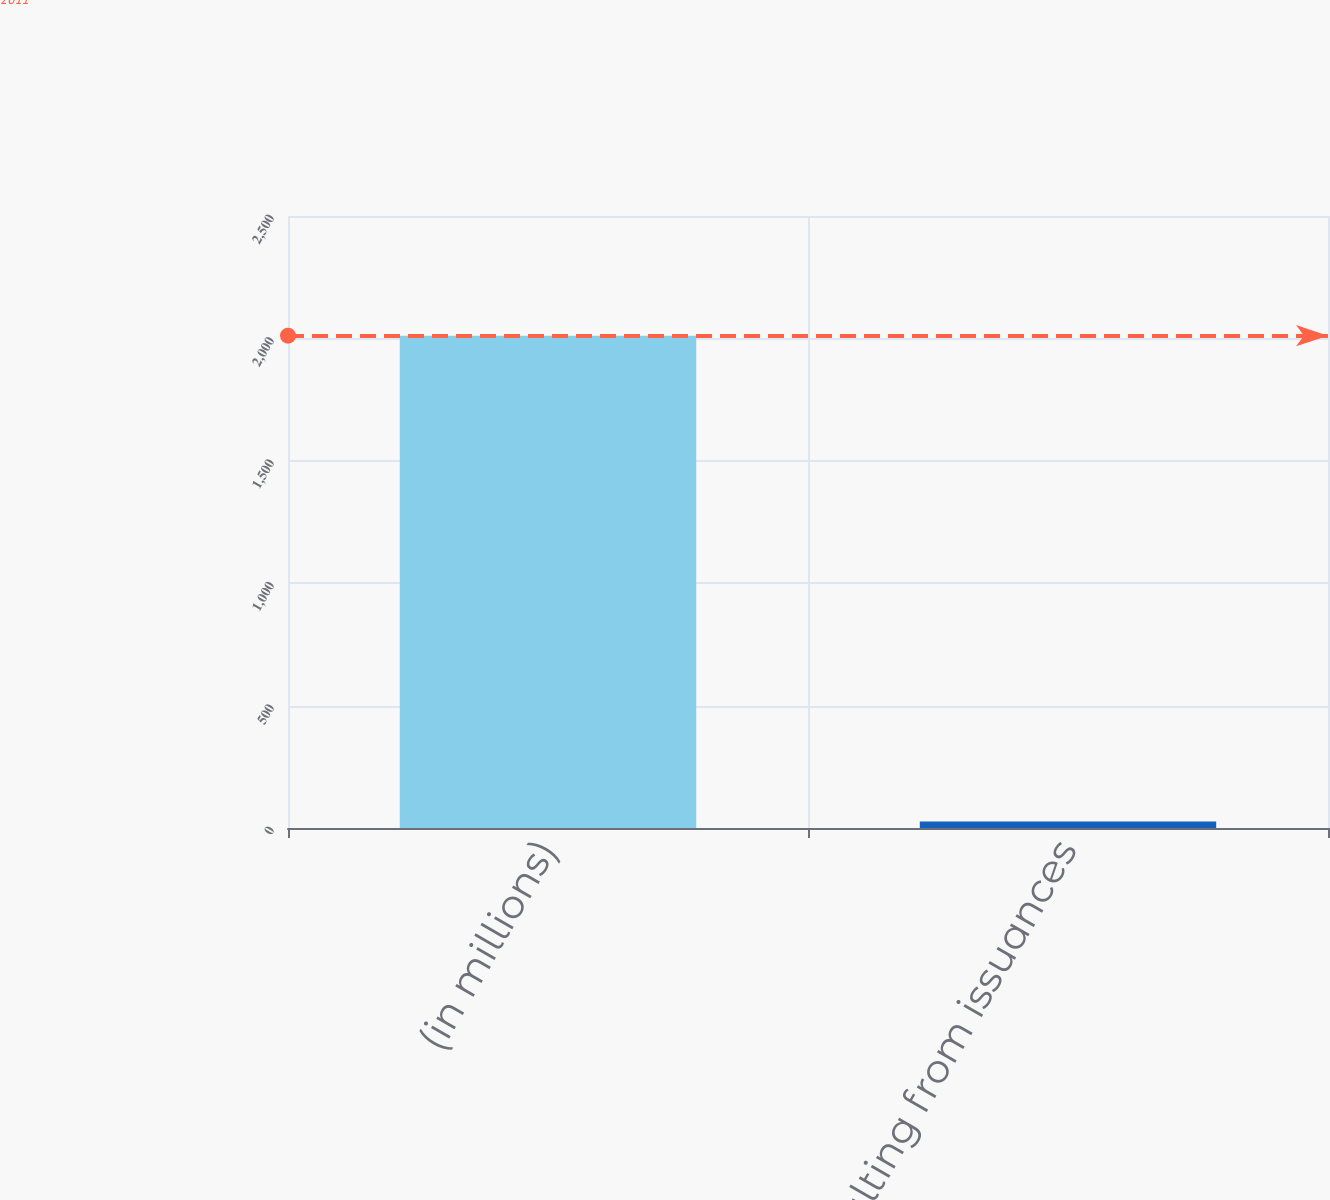Convert chart to OTSL. <chart><loc_0><loc_0><loc_500><loc_500><bar_chart><fcel>(in millions)<fcel>Gains resulting from issuances<nl><fcel>2011<fcel>27<nl></chart> 